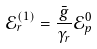Convert formula to latex. <formula><loc_0><loc_0><loc_500><loc_500>\mathcal { E } _ { r } ^ { ( 1 ) } = \frac { \bar { g } } { \gamma _ { r } } \mathcal { E } _ { p } ^ { 0 }</formula> 